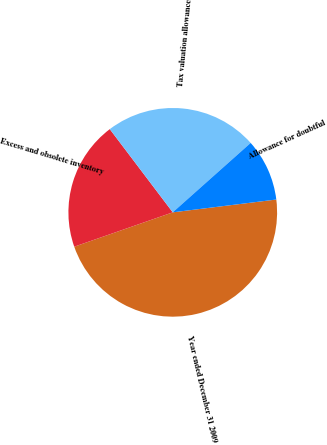Convert chart to OTSL. <chart><loc_0><loc_0><loc_500><loc_500><pie_chart><fcel>Year ended December 31 2009<fcel>Excess and obsolete inventory<fcel>Tax valuation allowance<fcel>Allowance for doubtful<nl><fcel>46.62%<fcel>20.03%<fcel>23.73%<fcel>9.62%<nl></chart> 